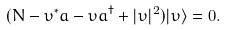<formula> <loc_0><loc_0><loc_500><loc_500>( N - \upsilon ^ { \ast } a - \upsilon a ^ { \dagger } + | \upsilon | ^ { 2 } ) | \upsilon \rangle = 0 .</formula> 